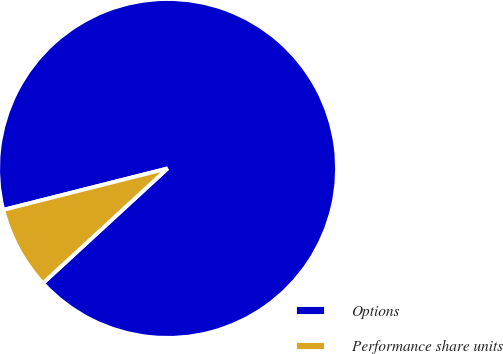Convert chart to OTSL. <chart><loc_0><loc_0><loc_500><loc_500><pie_chart><fcel>Options<fcel>Performance share units<nl><fcel>92.09%<fcel>7.91%<nl></chart> 